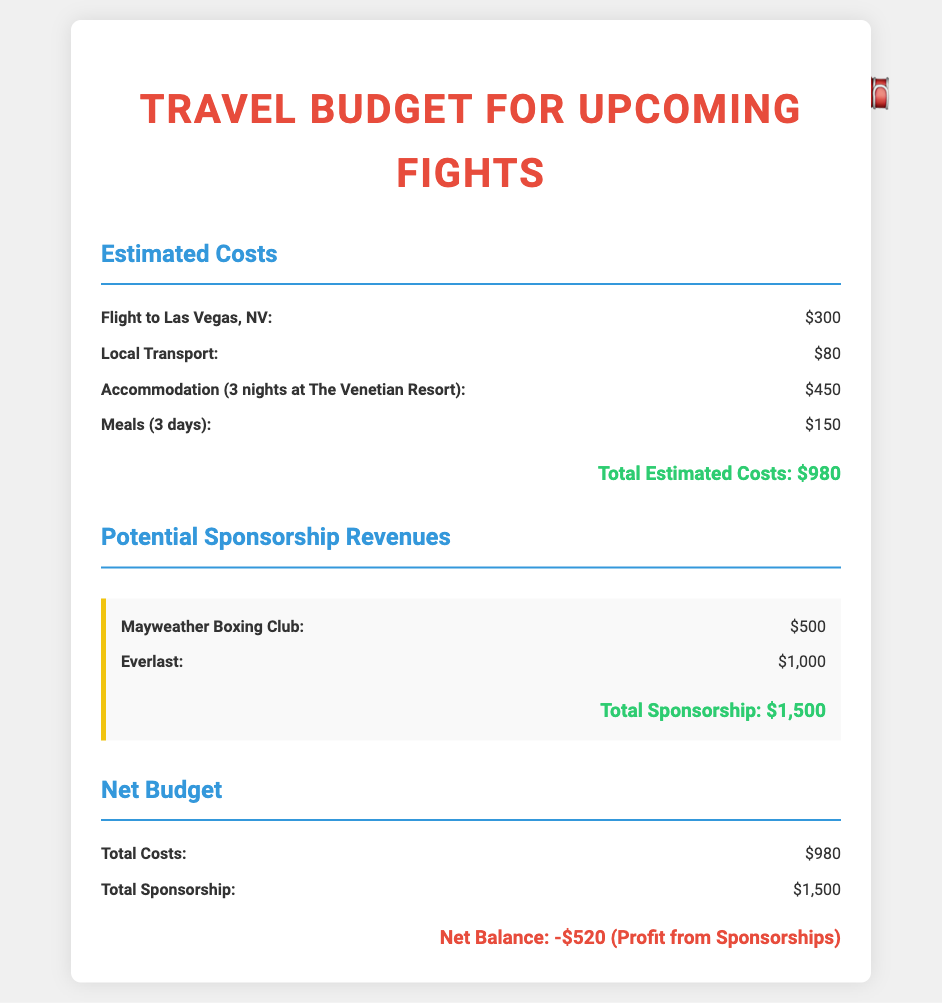What is the total estimated cost? The total estimated cost is stated at the bottom of the "Estimated Costs" section, which is $980.
Answer: $980 How much is the accommodation for 3 nights? The accommodation cost for 3 nights at The Venetian Resort is specifically mentioned as $450.
Answer: $450 What is the local transport cost? The cost for local transport is listed as $80 in the document.
Answer: $80 What is the total sponsorship revenue? The total sponsorship revenue is calculated and presented at the end of the "Potential Sponsorship Revenues" section, which amounts to $1,500.
Answer: $1,500 What is the net balance calculated from costs and sponsorships? The net balance is derived from subtracting total costs from total sponsorship, resulting in a negative balance of -$520.
Answer: -$520 How much is the meal cost for 3 days? The meal cost for 3 days is listed as $150 in the budget.
Answer: $150 What are the two sponsorship sources mentioned? The two sponsorship sources listed are Mayweather Boxing Club and Everlast.
Answer: Mayweather Boxing Club and Everlast How much will the flight to Las Vegas cost? The flight to Las Vegas, NV, is estimated to cost $300, as per the document details.
Answer: $300 What is the total estimated cost for transportation? The transportation cost includes the flight and local transport, summing up to $380 ($300 + $80).
Answer: $380 